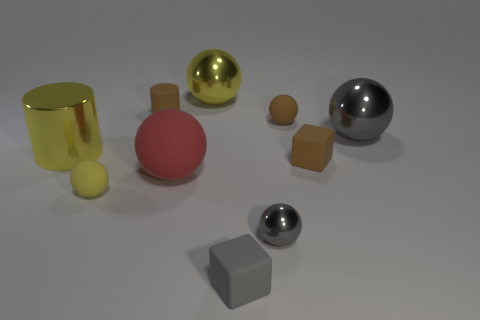Can you tell me how many objects are in the image and what their colors are? There are eight objects in the image. Starting from the top left and moving clockwise, there's a tall shiny yellow cylinder, a small yellow ball, a large shiny gold ball, a shiny gray ball, a tiny shiny silver ball, a matte tan cube, a large matte red sphere, and a matte gray cube. 